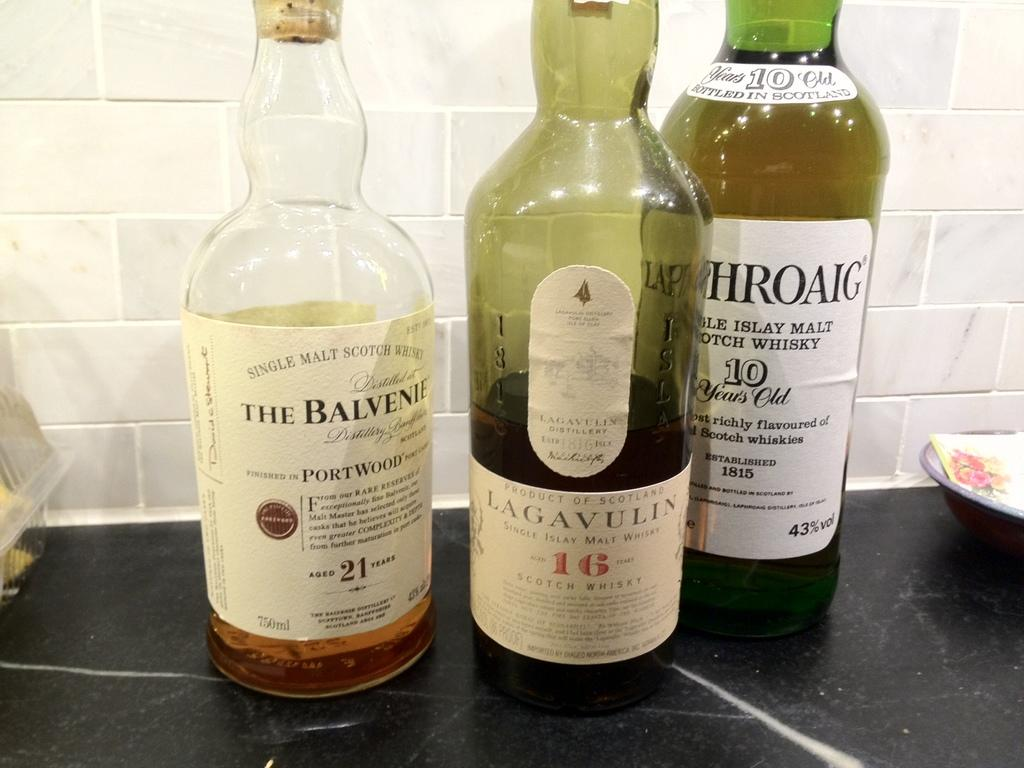<image>
Write a terse but informative summary of the picture. A collection of bottle in the middle called  Lagavulin. 